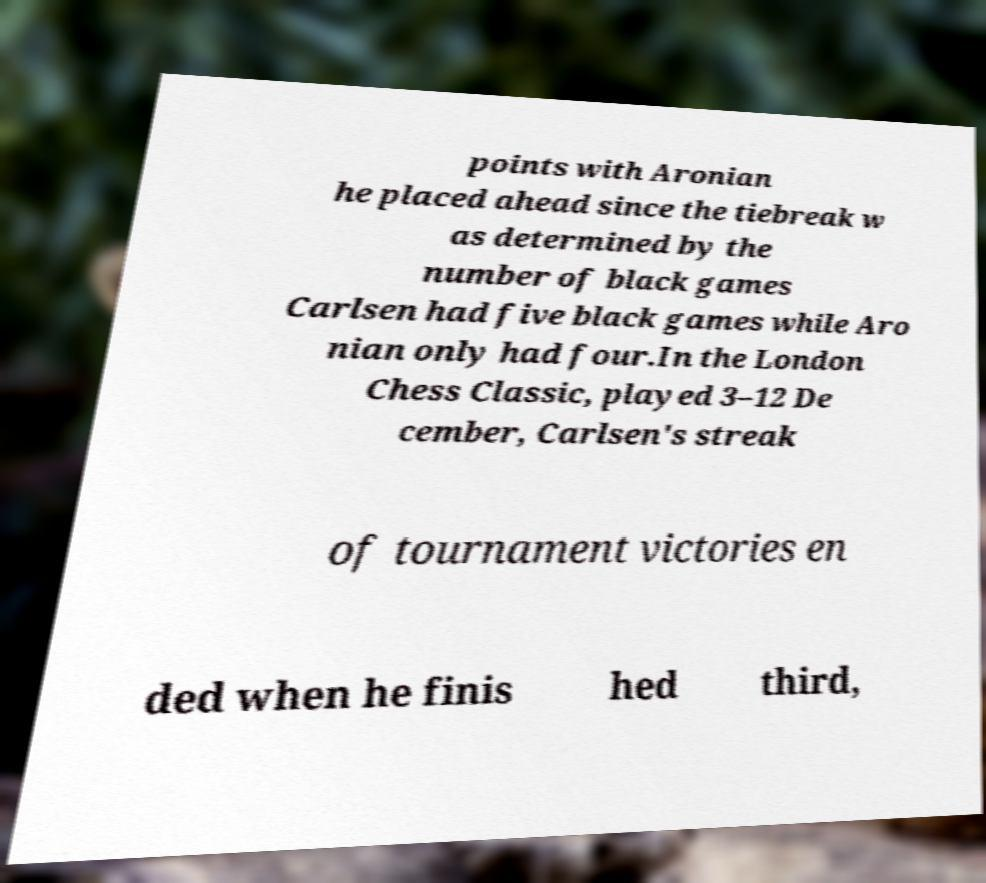Could you extract and type out the text from this image? points with Aronian he placed ahead since the tiebreak w as determined by the number of black games Carlsen had five black games while Aro nian only had four.In the London Chess Classic, played 3–12 De cember, Carlsen's streak of tournament victories en ded when he finis hed third, 